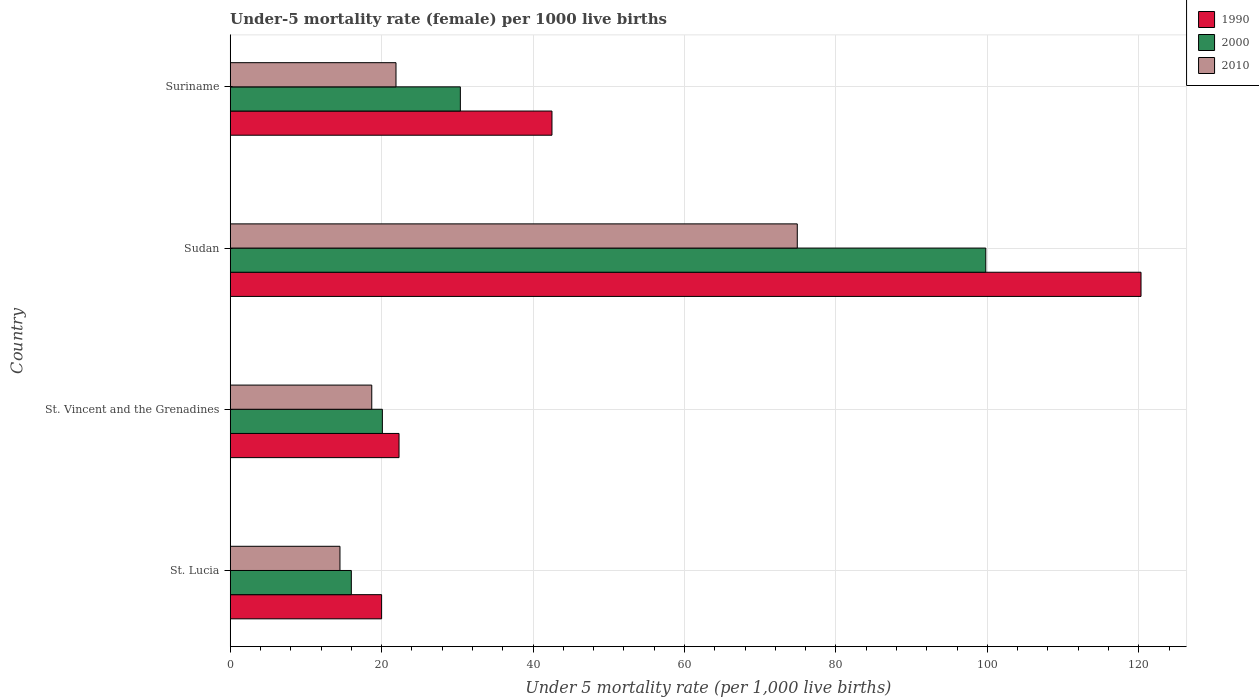How many different coloured bars are there?
Provide a short and direct response. 3. How many groups of bars are there?
Your response must be concise. 4. Are the number of bars per tick equal to the number of legend labels?
Make the answer very short. Yes. How many bars are there on the 1st tick from the bottom?
Offer a terse response. 3. What is the label of the 1st group of bars from the top?
Keep it short and to the point. Suriname. In how many cases, is the number of bars for a given country not equal to the number of legend labels?
Provide a short and direct response. 0. What is the under-five mortality rate in 2000 in Suriname?
Offer a terse response. 30.4. Across all countries, what is the maximum under-five mortality rate in 1990?
Make the answer very short. 120.3. Across all countries, what is the minimum under-five mortality rate in 2000?
Keep it short and to the point. 16. In which country was the under-five mortality rate in 2000 maximum?
Offer a terse response. Sudan. In which country was the under-five mortality rate in 2010 minimum?
Offer a very short reply. St. Lucia. What is the total under-five mortality rate in 2010 in the graph?
Your answer should be compact. 130. What is the difference between the under-five mortality rate in 1990 in St. Vincent and the Grenadines and that in Suriname?
Ensure brevity in your answer.  -20.2. What is the difference between the under-five mortality rate in 2000 in Suriname and the under-five mortality rate in 2010 in St. Lucia?
Keep it short and to the point. 15.9. What is the average under-five mortality rate in 1990 per country?
Provide a short and direct response. 51.27. What is the difference between the under-five mortality rate in 1990 and under-five mortality rate in 2000 in St. Vincent and the Grenadines?
Keep it short and to the point. 2.2. What is the ratio of the under-five mortality rate in 1990 in St. Vincent and the Grenadines to that in Sudan?
Provide a succinct answer. 0.19. What is the difference between the highest and the second highest under-five mortality rate in 2010?
Offer a terse response. 53. What is the difference between the highest and the lowest under-five mortality rate in 2010?
Keep it short and to the point. 60.4. In how many countries, is the under-five mortality rate in 2010 greater than the average under-five mortality rate in 2010 taken over all countries?
Provide a succinct answer. 1. What does the 1st bar from the bottom in St. Vincent and the Grenadines represents?
Your answer should be very brief. 1990. Is it the case that in every country, the sum of the under-five mortality rate in 2000 and under-five mortality rate in 1990 is greater than the under-five mortality rate in 2010?
Provide a succinct answer. Yes. How many bars are there?
Ensure brevity in your answer.  12. How many countries are there in the graph?
Your answer should be very brief. 4. What is the difference between two consecutive major ticks on the X-axis?
Your answer should be compact. 20. Are the values on the major ticks of X-axis written in scientific E-notation?
Offer a terse response. No. Does the graph contain any zero values?
Your answer should be compact. No. Where does the legend appear in the graph?
Give a very brief answer. Top right. How many legend labels are there?
Give a very brief answer. 3. How are the legend labels stacked?
Give a very brief answer. Vertical. What is the title of the graph?
Offer a very short reply. Under-5 mortality rate (female) per 1000 live births. Does "2010" appear as one of the legend labels in the graph?
Keep it short and to the point. Yes. What is the label or title of the X-axis?
Offer a very short reply. Under 5 mortality rate (per 1,0 live births). What is the Under 5 mortality rate (per 1,000 live births) in 2000 in St. Lucia?
Your response must be concise. 16. What is the Under 5 mortality rate (per 1,000 live births) in 1990 in St. Vincent and the Grenadines?
Offer a terse response. 22.3. What is the Under 5 mortality rate (per 1,000 live births) of 2000 in St. Vincent and the Grenadines?
Offer a very short reply. 20.1. What is the Under 5 mortality rate (per 1,000 live births) of 1990 in Sudan?
Your response must be concise. 120.3. What is the Under 5 mortality rate (per 1,000 live births) in 2000 in Sudan?
Offer a terse response. 99.8. What is the Under 5 mortality rate (per 1,000 live births) in 2010 in Sudan?
Ensure brevity in your answer.  74.9. What is the Under 5 mortality rate (per 1,000 live births) in 1990 in Suriname?
Offer a terse response. 42.5. What is the Under 5 mortality rate (per 1,000 live births) of 2000 in Suriname?
Your response must be concise. 30.4. What is the Under 5 mortality rate (per 1,000 live births) in 2010 in Suriname?
Your response must be concise. 21.9. Across all countries, what is the maximum Under 5 mortality rate (per 1,000 live births) of 1990?
Keep it short and to the point. 120.3. Across all countries, what is the maximum Under 5 mortality rate (per 1,000 live births) of 2000?
Offer a terse response. 99.8. Across all countries, what is the maximum Under 5 mortality rate (per 1,000 live births) of 2010?
Give a very brief answer. 74.9. Across all countries, what is the minimum Under 5 mortality rate (per 1,000 live births) in 2000?
Your answer should be very brief. 16. What is the total Under 5 mortality rate (per 1,000 live births) in 1990 in the graph?
Keep it short and to the point. 205.1. What is the total Under 5 mortality rate (per 1,000 live births) of 2000 in the graph?
Make the answer very short. 166.3. What is the total Under 5 mortality rate (per 1,000 live births) of 2010 in the graph?
Keep it short and to the point. 130. What is the difference between the Under 5 mortality rate (per 1,000 live births) in 1990 in St. Lucia and that in Sudan?
Offer a terse response. -100.3. What is the difference between the Under 5 mortality rate (per 1,000 live births) of 2000 in St. Lucia and that in Sudan?
Offer a very short reply. -83.8. What is the difference between the Under 5 mortality rate (per 1,000 live births) of 2010 in St. Lucia and that in Sudan?
Provide a succinct answer. -60.4. What is the difference between the Under 5 mortality rate (per 1,000 live births) of 1990 in St. Lucia and that in Suriname?
Offer a very short reply. -22.5. What is the difference between the Under 5 mortality rate (per 1,000 live births) of 2000 in St. Lucia and that in Suriname?
Offer a very short reply. -14.4. What is the difference between the Under 5 mortality rate (per 1,000 live births) in 1990 in St. Vincent and the Grenadines and that in Sudan?
Make the answer very short. -98. What is the difference between the Under 5 mortality rate (per 1,000 live births) in 2000 in St. Vincent and the Grenadines and that in Sudan?
Provide a short and direct response. -79.7. What is the difference between the Under 5 mortality rate (per 1,000 live births) in 2010 in St. Vincent and the Grenadines and that in Sudan?
Your answer should be compact. -56.2. What is the difference between the Under 5 mortality rate (per 1,000 live births) of 1990 in St. Vincent and the Grenadines and that in Suriname?
Make the answer very short. -20.2. What is the difference between the Under 5 mortality rate (per 1,000 live births) in 2010 in St. Vincent and the Grenadines and that in Suriname?
Give a very brief answer. -3.2. What is the difference between the Under 5 mortality rate (per 1,000 live births) of 1990 in Sudan and that in Suriname?
Your response must be concise. 77.8. What is the difference between the Under 5 mortality rate (per 1,000 live births) in 2000 in Sudan and that in Suriname?
Make the answer very short. 69.4. What is the difference between the Under 5 mortality rate (per 1,000 live births) of 1990 in St. Lucia and the Under 5 mortality rate (per 1,000 live births) of 2000 in St. Vincent and the Grenadines?
Offer a very short reply. -0.1. What is the difference between the Under 5 mortality rate (per 1,000 live births) in 1990 in St. Lucia and the Under 5 mortality rate (per 1,000 live births) in 2010 in St. Vincent and the Grenadines?
Your response must be concise. 1.3. What is the difference between the Under 5 mortality rate (per 1,000 live births) in 1990 in St. Lucia and the Under 5 mortality rate (per 1,000 live births) in 2000 in Sudan?
Keep it short and to the point. -79.8. What is the difference between the Under 5 mortality rate (per 1,000 live births) in 1990 in St. Lucia and the Under 5 mortality rate (per 1,000 live births) in 2010 in Sudan?
Provide a short and direct response. -54.9. What is the difference between the Under 5 mortality rate (per 1,000 live births) of 2000 in St. Lucia and the Under 5 mortality rate (per 1,000 live births) of 2010 in Sudan?
Your answer should be very brief. -58.9. What is the difference between the Under 5 mortality rate (per 1,000 live births) of 1990 in St. Lucia and the Under 5 mortality rate (per 1,000 live births) of 2000 in Suriname?
Provide a short and direct response. -10.4. What is the difference between the Under 5 mortality rate (per 1,000 live births) of 1990 in St. Lucia and the Under 5 mortality rate (per 1,000 live births) of 2010 in Suriname?
Offer a very short reply. -1.9. What is the difference between the Under 5 mortality rate (per 1,000 live births) in 1990 in St. Vincent and the Grenadines and the Under 5 mortality rate (per 1,000 live births) in 2000 in Sudan?
Your answer should be very brief. -77.5. What is the difference between the Under 5 mortality rate (per 1,000 live births) of 1990 in St. Vincent and the Grenadines and the Under 5 mortality rate (per 1,000 live births) of 2010 in Sudan?
Make the answer very short. -52.6. What is the difference between the Under 5 mortality rate (per 1,000 live births) in 2000 in St. Vincent and the Grenadines and the Under 5 mortality rate (per 1,000 live births) in 2010 in Sudan?
Make the answer very short. -54.8. What is the difference between the Under 5 mortality rate (per 1,000 live births) in 1990 in Sudan and the Under 5 mortality rate (per 1,000 live births) in 2000 in Suriname?
Give a very brief answer. 89.9. What is the difference between the Under 5 mortality rate (per 1,000 live births) of 1990 in Sudan and the Under 5 mortality rate (per 1,000 live births) of 2010 in Suriname?
Keep it short and to the point. 98.4. What is the difference between the Under 5 mortality rate (per 1,000 live births) in 2000 in Sudan and the Under 5 mortality rate (per 1,000 live births) in 2010 in Suriname?
Offer a terse response. 77.9. What is the average Under 5 mortality rate (per 1,000 live births) of 1990 per country?
Offer a very short reply. 51.27. What is the average Under 5 mortality rate (per 1,000 live births) of 2000 per country?
Offer a very short reply. 41.58. What is the average Under 5 mortality rate (per 1,000 live births) of 2010 per country?
Offer a terse response. 32.5. What is the difference between the Under 5 mortality rate (per 1,000 live births) in 1990 and Under 5 mortality rate (per 1,000 live births) in 2000 in St. Lucia?
Keep it short and to the point. 4. What is the difference between the Under 5 mortality rate (per 1,000 live births) of 1990 and Under 5 mortality rate (per 1,000 live births) of 2010 in St. Lucia?
Offer a terse response. 5.5. What is the difference between the Under 5 mortality rate (per 1,000 live births) of 1990 and Under 5 mortality rate (per 1,000 live births) of 2000 in St. Vincent and the Grenadines?
Offer a very short reply. 2.2. What is the difference between the Under 5 mortality rate (per 1,000 live births) in 1990 and Under 5 mortality rate (per 1,000 live births) in 2000 in Sudan?
Your answer should be compact. 20.5. What is the difference between the Under 5 mortality rate (per 1,000 live births) of 1990 and Under 5 mortality rate (per 1,000 live births) of 2010 in Sudan?
Make the answer very short. 45.4. What is the difference between the Under 5 mortality rate (per 1,000 live births) in 2000 and Under 5 mortality rate (per 1,000 live births) in 2010 in Sudan?
Keep it short and to the point. 24.9. What is the difference between the Under 5 mortality rate (per 1,000 live births) in 1990 and Under 5 mortality rate (per 1,000 live births) in 2000 in Suriname?
Offer a terse response. 12.1. What is the difference between the Under 5 mortality rate (per 1,000 live births) of 1990 and Under 5 mortality rate (per 1,000 live births) of 2010 in Suriname?
Provide a succinct answer. 20.6. What is the difference between the Under 5 mortality rate (per 1,000 live births) of 2000 and Under 5 mortality rate (per 1,000 live births) of 2010 in Suriname?
Make the answer very short. 8.5. What is the ratio of the Under 5 mortality rate (per 1,000 live births) of 1990 in St. Lucia to that in St. Vincent and the Grenadines?
Offer a terse response. 0.9. What is the ratio of the Under 5 mortality rate (per 1,000 live births) of 2000 in St. Lucia to that in St. Vincent and the Grenadines?
Give a very brief answer. 0.8. What is the ratio of the Under 5 mortality rate (per 1,000 live births) of 2010 in St. Lucia to that in St. Vincent and the Grenadines?
Give a very brief answer. 0.78. What is the ratio of the Under 5 mortality rate (per 1,000 live births) of 1990 in St. Lucia to that in Sudan?
Ensure brevity in your answer.  0.17. What is the ratio of the Under 5 mortality rate (per 1,000 live births) of 2000 in St. Lucia to that in Sudan?
Your answer should be compact. 0.16. What is the ratio of the Under 5 mortality rate (per 1,000 live births) of 2010 in St. Lucia to that in Sudan?
Provide a succinct answer. 0.19. What is the ratio of the Under 5 mortality rate (per 1,000 live births) in 1990 in St. Lucia to that in Suriname?
Offer a very short reply. 0.47. What is the ratio of the Under 5 mortality rate (per 1,000 live births) of 2000 in St. Lucia to that in Suriname?
Your answer should be compact. 0.53. What is the ratio of the Under 5 mortality rate (per 1,000 live births) in 2010 in St. Lucia to that in Suriname?
Your response must be concise. 0.66. What is the ratio of the Under 5 mortality rate (per 1,000 live births) of 1990 in St. Vincent and the Grenadines to that in Sudan?
Your answer should be very brief. 0.19. What is the ratio of the Under 5 mortality rate (per 1,000 live births) of 2000 in St. Vincent and the Grenadines to that in Sudan?
Provide a short and direct response. 0.2. What is the ratio of the Under 5 mortality rate (per 1,000 live births) in 2010 in St. Vincent and the Grenadines to that in Sudan?
Offer a very short reply. 0.25. What is the ratio of the Under 5 mortality rate (per 1,000 live births) in 1990 in St. Vincent and the Grenadines to that in Suriname?
Make the answer very short. 0.52. What is the ratio of the Under 5 mortality rate (per 1,000 live births) in 2000 in St. Vincent and the Grenadines to that in Suriname?
Offer a terse response. 0.66. What is the ratio of the Under 5 mortality rate (per 1,000 live births) of 2010 in St. Vincent and the Grenadines to that in Suriname?
Provide a succinct answer. 0.85. What is the ratio of the Under 5 mortality rate (per 1,000 live births) of 1990 in Sudan to that in Suriname?
Keep it short and to the point. 2.83. What is the ratio of the Under 5 mortality rate (per 1,000 live births) in 2000 in Sudan to that in Suriname?
Your answer should be compact. 3.28. What is the ratio of the Under 5 mortality rate (per 1,000 live births) in 2010 in Sudan to that in Suriname?
Make the answer very short. 3.42. What is the difference between the highest and the second highest Under 5 mortality rate (per 1,000 live births) in 1990?
Keep it short and to the point. 77.8. What is the difference between the highest and the second highest Under 5 mortality rate (per 1,000 live births) of 2000?
Offer a very short reply. 69.4. What is the difference between the highest and the lowest Under 5 mortality rate (per 1,000 live births) in 1990?
Provide a succinct answer. 100.3. What is the difference between the highest and the lowest Under 5 mortality rate (per 1,000 live births) in 2000?
Give a very brief answer. 83.8. What is the difference between the highest and the lowest Under 5 mortality rate (per 1,000 live births) of 2010?
Provide a short and direct response. 60.4. 